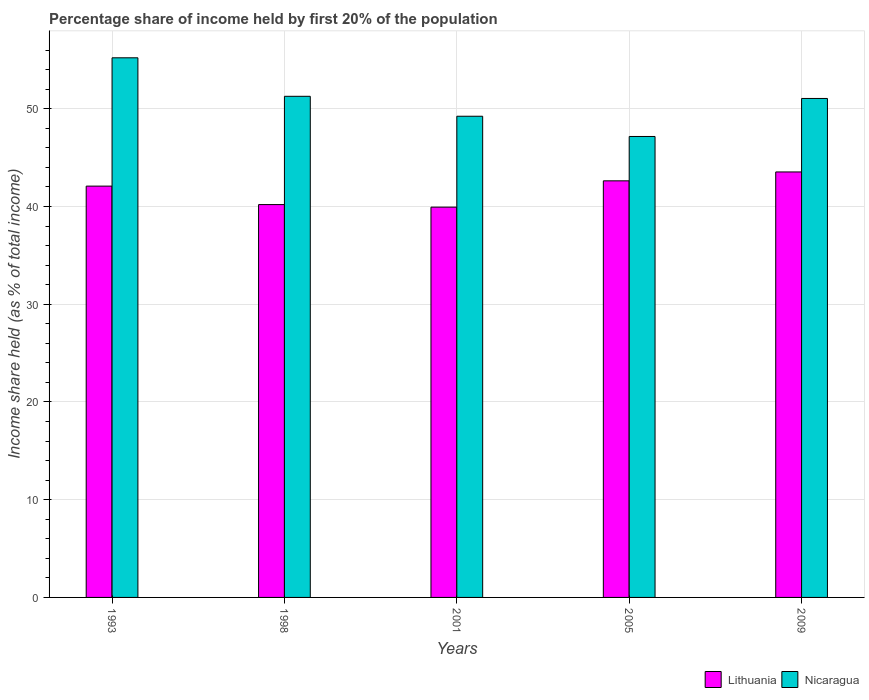How many groups of bars are there?
Ensure brevity in your answer.  5. What is the label of the 1st group of bars from the left?
Your answer should be very brief. 1993. In how many cases, is the number of bars for a given year not equal to the number of legend labels?
Provide a succinct answer. 0. What is the share of income held by first 20% of the population in Nicaragua in 1998?
Provide a short and direct response. 51.28. Across all years, what is the maximum share of income held by first 20% of the population in Lithuania?
Your answer should be compact. 43.54. Across all years, what is the minimum share of income held by first 20% of the population in Nicaragua?
Ensure brevity in your answer.  47.17. In which year was the share of income held by first 20% of the population in Nicaragua maximum?
Your answer should be compact. 1993. What is the total share of income held by first 20% of the population in Nicaragua in the graph?
Keep it short and to the point. 253.97. What is the difference between the share of income held by first 20% of the population in Nicaragua in 1993 and that in 2009?
Make the answer very short. 4.16. What is the difference between the share of income held by first 20% of the population in Lithuania in 2009 and the share of income held by first 20% of the population in Nicaragua in 2001?
Your answer should be compact. -5.7. What is the average share of income held by first 20% of the population in Lithuania per year?
Give a very brief answer. 41.68. In the year 2005, what is the difference between the share of income held by first 20% of the population in Nicaragua and share of income held by first 20% of the population in Lithuania?
Give a very brief answer. 4.54. What is the ratio of the share of income held by first 20% of the population in Nicaragua in 2001 to that in 2005?
Your answer should be very brief. 1.04. Is the share of income held by first 20% of the population in Lithuania in 1998 less than that in 2005?
Keep it short and to the point. Yes. What is the difference between the highest and the second highest share of income held by first 20% of the population in Nicaragua?
Provide a succinct answer. 3.94. What is the difference between the highest and the lowest share of income held by first 20% of the population in Lithuania?
Make the answer very short. 3.6. Is the sum of the share of income held by first 20% of the population in Lithuania in 2001 and 2009 greater than the maximum share of income held by first 20% of the population in Nicaragua across all years?
Offer a very short reply. Yes. What does the 2nd bar from the left in 2001 represents?
Your response must be concise. Nicaragua. What does the 1st bar from the right in 1993 represents?
Give a very brief answer. Nicaragua. How many bars are there?
Offer a terse response. 10. How many years are there in the graph?
Offer a very short reply. 5. What is the difference between two consecutive major ticks on the Y-axis?
Keep it short and to the point. 10. Does the graph contain any zero values?
Make the answer very short. No. How are the legend labels stacked?
Provide a succinct answer. Horizontal. What is the title of the graph?
Your answer should be very brief. Percentage share of income held by first 20% of the population. What is the label or title of the Y-axis?
Keep it short and to the point. Income share held (as % of total income). What is the Income share held (as % of total income) of Lithuania in 1993?
Provide a succinct answer. 42.09. What is the Income share held (as % of total income) of Nicaragua in 1993?
Your answer should be compact. 55.22. What is the Income share held (as % of total income) of Lithuania in 1998?
Offer a terse response. 40.2. What is the Income share held (as % of total income) in Nicaragua in 1998?
Provide a succinct answer. 51.28. What is the Income share held (as % of total income) in Lithuania in 2001?
Offer a terse response. 39.94. What is the Income share held (as % of total income) of Nicaragua in 2001?
Offer a terse response. 49.24. What is the Income share held (as % of total income) in Lithuania in 2005?
Provide a succinct answer. 42.63. What is the Income share held (as % of total income) of Nicaragua in 2005?
Offer a very short reply. 47.17. What is the Income share held (as % of total income) of Lithuania in 2009?
Make the answer very short. 43.54. What is the Income share held (as % of total income) of Nicaragua in 2009?
Give a very brief answer. 51.06. Across all years, what is the maximum Income share held (as % of total income) in Lithuania?
Your response must be concise. 43.54. Across all years, what is the maximum Income share held (as % of total income) of Nicaragua?
Ensure brevity in your answer.  55.22. Across all years, what is the minimum Income share held (as % of total income) of Lithuania?
Provide a short and direct response. 39.94. Across all years, what is the minimum Income share held (as % of total income) in Nicaragua?
Ensure brevity in your answer.  47.17. What is the total Income share held (as % of total income) in Lithuania in the graph?
Offer a very short reply. 208.4. What is the total Income share held (as % of total income) in Nicaragua in the graph?
Your answer should be very brief. 253.97. What is the difference between the Income share held (as % of total income) in Lithuania in 1993 and that in 1998?
Give a very brief answer. 1.89. What is the difference between the Income share held (as % of total income) of Nicaragua in 1993 and that in 1998?
Keep it short and to the point. 3.94. What is the difference between the Income share held (as % of total income) in Lithuania in 1993 and that in 2001?
Your response must be concise. 2.15. What is the difference between the Income share held (as % of total income) of Nicaragua in 1993 and that in 2001?
Provide a succinct answer. 5.98. What is the difference between the Income share held (as % of total income) of Lithuania in 1993 and that in 2005?
Keep it short and to the point. -0.54. What is the difference between the Income share held (as % of total income) of Nicaragua in 1993 and that in 2005?
Keep it short and to the point. 8.05. What is the difference between the Income share held (as % of total income) of Lithuania in 1993 and that in 2009?
Offer a terse response. -1.45. What is the difference between the Income share held (as % of total income) of Nicaragua in 1993 and that in 2009?
Your answer should be very brief. 4.16. What is the difference between the Income share held (as % of total income) of Lithuania in 1998 and that in 2001?
Your answer should be compact. 0.26. What is the difference between the Income share held (as % of total income) in Nicaragua in 1998 and that in 2001?
Ensure brevity in your answer.  2.04. What is the difference between the Income share held (as % of total income) in Lithuania in 1998 and that in 2005?
Ensure brevity in your answer.  -2.43. What is the difference between the Income share held (as % of total income) in Nicaragua in 1998 and that in 2005?
Your answer should be very brief. 4.11. What is the difference between the Income share held (as % of total income) of Lithuania in 1998 and that in 2009?
Make the answer very short. -3.34. What is the difference between the Income share held (as % of total income) in Nicaragua in 1998 and that in 2009?
Ensure brevity in your answer.  0.22. What is the difference between the Income share held (as % of total income) of Lithuania in 2001 and that in 2005?
Your response must be concise. -2.69. What is the difference between the Income share held (as % of total income) in Nicaragua in 2001 and that in 2005?
Offer a very short reply. 2.07. What is the difference between the Income share held (as % of total income) of Lithuania in 2001 and that in 2009?
Keep it short and to the point. -3.6. What is the difference between the Income share held (as % of total income) of Nicaragua in 2001 and that in 2009?
Your response must be concise. -1.82. What is the difference between the Income share held (as % of total income) of Lithuania in 2005 and that in 2009?
Your answer should be compact. -0.91. What is the difference between the Income share held (as % of total income) in Nicaragua in 2005 and that in 2009?
Offer a terse response. -3.89. What is the difference between the Income share held (as % of total income) of Lithuania in 1993 and the Income share held (as % of total income) of Nicaragua in 1998?
Your answer should be compact. -9.19. What is the difference between the Income share held (as % of total income) of Lithuania in 1993 and the Income share held (as % of total income) of Nicaragua in 2001?
Your answer should be very brief. -7.15. What is the difference between the Income share held (as % of total income) in Lithuania in 1993 and the Income share held (as % of total income) in Nicaragua in 2005?
Your answer should be very brief. -5.08. What is the difference between the Income share held (as % of total income) in Lithuania in 1993 and the Income share held (as % of total income) in Nicaragua in 2009?
Offer a terse response. -8.97. What is the difference between the Income share held (as % of total income) in Lithuania in 1998 and the Income share held (as % of total income) in Nicaragua in 2001?
Provide a short and direct response. -9.04. What is the difference between the Income share held (as % of total income) in Lithuania in 1998 and the Income share held (as % of total income) in Nicaragua in 2005?
Your response must be concise. -6.97. What is the difference between the Income share held (as % of total income) in Lithuania in 1998 and the Income share held (as % of total income) in Nicaragua in 2009?
Your response must be concise. -10.86. What is the difference between the Income share held (as % of total income) of Lithuania in 2001 and the Income share held (as % of total income) of Nicaragua in 2005?
Offer a very short reply. -7.23. What is the difference between the Income share held (as % of total income) of Lithuania in 2001 and the Income share held (as % of total income) of Nicaragua in 2009?
Give a very brief answer. -11.12. What is the difference between the Income share held (as % of total income) in Lithuania in 2005 and the Income share held (as % of total income) in Nicaragua in 2009?
Offer a terse response. -8.43. What is the average Income share held (as % of total income) in Lithuania per year?
Your response must be concise. 41.68. What is the average Income share held (as % of total income) of Nicaragua per year?
Give a very brief answer. 50.79. In the year 1993, what is the difference between the Income share held (as % of total income) in Lithuania and Income share held (as % of total income) in Nicaragua?
Provide a succinct answer. -13.13. In the year 1998, what is the difference between the Income share held (as % of total income) of Lithuania and Income share held (as % of total income) of Nicaragua?
Your answer should be very brief. -11.08. In the year 2001, what is the difference between the Income share held (as % of total income) in Lithuania and Income share held (as % of total income) in Nicaragua?
Offer a very short reply. -9.3. In the year 2005, what is the difference between the Income share held (as % of total income) of Lithuania and Income share held (as % of total income) of Nicaragua?
Ensure brevity in your answer.  -4.54. In the year 2009, what is the difference between the Income share held (as % of total income) of Lithuania and Income share held (as % of total income) of Nicaragua?
Provide a succinct answer. -7.52. What is the ratio of the Income share held (as % of total income) of Lithuania in 1993 to that in 1998?
Ensure brevity in your answer.  1.05. What is the ratio of the Income share held (as % of total income) in Nicaragua in 1993 to that in 1998?
Provide a succinct answer. 1.08. What is the ratio of the Income share held (as % of total income) in Lithuania in 1993 to that in 2001?
Your answer should be compact. 1.05. What is the ratio of the Income share held (as % of total income) of Nicaragua in 1993 to that in 2001?
Your answer should be very brief. 1.12. What is the ratio of the Income share held (as % of total income) of Lithuania in 1993 to that in 2005?
Offer a very short reply. 0.99. What is the ratio of the Income share held (as % of total income) in Nicaragua in 1993 to that in 2005?
Your answer should be very brief. 1.17. What is the ratio of the Income share held (as % of total income) of Lithuania in 1993 to that in 2009?
Provide a succinct answer. 0.97. What is the ratio of the Income share held (as % of total income) of Nicaragua in 1993 to that in 2009?
Your answer should be compact. 1.08. What is the ratio of the Income share held (as % of total income) in Lithuania in 1998 to that in 2001?
Give a very brief answer. 1.01. What is the ratio of the Income share held (as % of total income) of Nicaragua in 1998 to that in 2001?
Offer a terse response. 1.04. What is the ratio of the Income share held (as % of total income) of Lithuania in 1998 to that in 2005?
Your response must be concise. 0.94. What is the ratio of the Income share held (as % of total income) in Nicaragua in 1998 to that in 2005?
Provide a succinct answer. 1.09. What is the ratio of the Income share held (as % of total income) of Lithuania in 1998 to that in 2009?
Offer a terse response. 0.92. What is the ratio of the Income share held (as % of total income) in Nicaragua in 1998 to that in 2009?
Your answer should be very brief. 1. What is the ratio of the Income share held (as % of total income) in Lithuania in 2001 to that in 2005?
Make the answer very short. 0.94. What is the ratio of the Income share held (as % of total income) in Nicaragua in 2001 to that in 2005?
Give a very brief answer. 1.04. What is the ratio of the Income share held (as % of total income) of Lithuania in 2001 to that in 2009?
Your answer should be compact. 0.92. What is the ratio of the Income share held (as % of total income) in Nicaragua in 2001 to that in 2009?
Ensure brevity in your answer.  0.96. What is the ratio of the Income share held (as % of total income) of Lithuania in 2005 to that in 2009?
Give a very brief answer. 0.98. What is the ratio of the Income share held (as % of total income) of Nicaragua in 2005 to that in 2009?
Offer a very short reply. 0.92. What is the difference between the highest and the second highest Income share held (as % of total income) in Lithuania?
Keep it short and to the point. 0.91. What is the difference between the highest and the second highest Income share held (as % of total income) in Nicaragua?
Keep it short and to the point. 3.94. What is the difference between the highest and the lowest Income share held (as % of total income) of Nicaragua?
Your response must be concise. 8.05. 